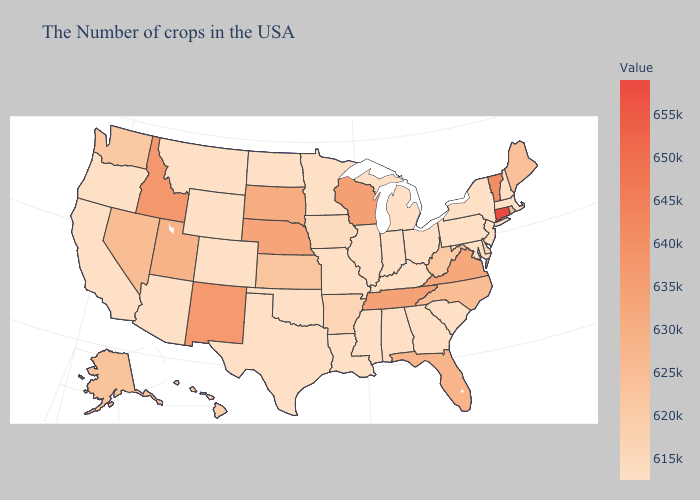Does South Dakota have the lowest value in the MidWest?
Answer briefly. No. Does Texas have the lowest value in the South?
Write a very short answer. Yes. Does Connecticut have the highest value in the Northeast?
Be succinct. Yes. Does New Mexico have the lowest value in the USA?
Keep it brief. No. Does Alabama have a higher value than Kansas?
Give a very brief answer. No. Is the legend a continuous bar?
Keep it brief. Yes. 